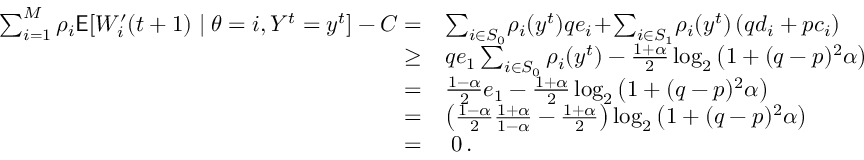Convert formula to latex. <formula><loc_0><loc_0><loc_500><loc_500>\begin{array} { r l } { \sum _ { i = 1 } ^ { M } \rho _ { i } E [ W _ { i } ^ { \prime } ( t + 1 ) | \theta = i , Y ^ { t } = y ^ { t } ] - C = } & { \sum _ { i \in S _ { 0 } } \, \rho _ { i } ( y ^ { t } ) q e _ { i } \, + \, \sum _ { i \in S _ { 1 } } \, \rho _ { i } ( y ^ { t } ) \left ( q d _ { i } + p c _ { i } \right ) } \\ { \geq } & { q e _ { 1 } \sum _ { i \in S _ { 0 } } \rho _ { i } ( y ^ { t } ) - \frac { 1 + \alpha } { 2 } \log _ { 2 } \left ( 1 + ( q - p ) ^ { 2 } \alpha \right ) } \\ { = } & { \frac { 1 - \alpha } { 2 } e _ { 1 } - \frac { 1 + \alpha } { 2 } \log _ { 2 } \left ( 1 + ( q - p ) ^ { 2 } \alpha \right ) } \\ { = } & { \left ( \frac { 1 - \alpha } { 2 } \frac { 1 + \alpha } { 1 - \alpha } - \frac { 1 + \alpha } { 2 } \right ) \log _ { 2 } \left ( 1 + ( q - p ) ^ { 2 } \alpha \right ) } \\ { = } & { \, 0 \, . } \end{array}</formula> 